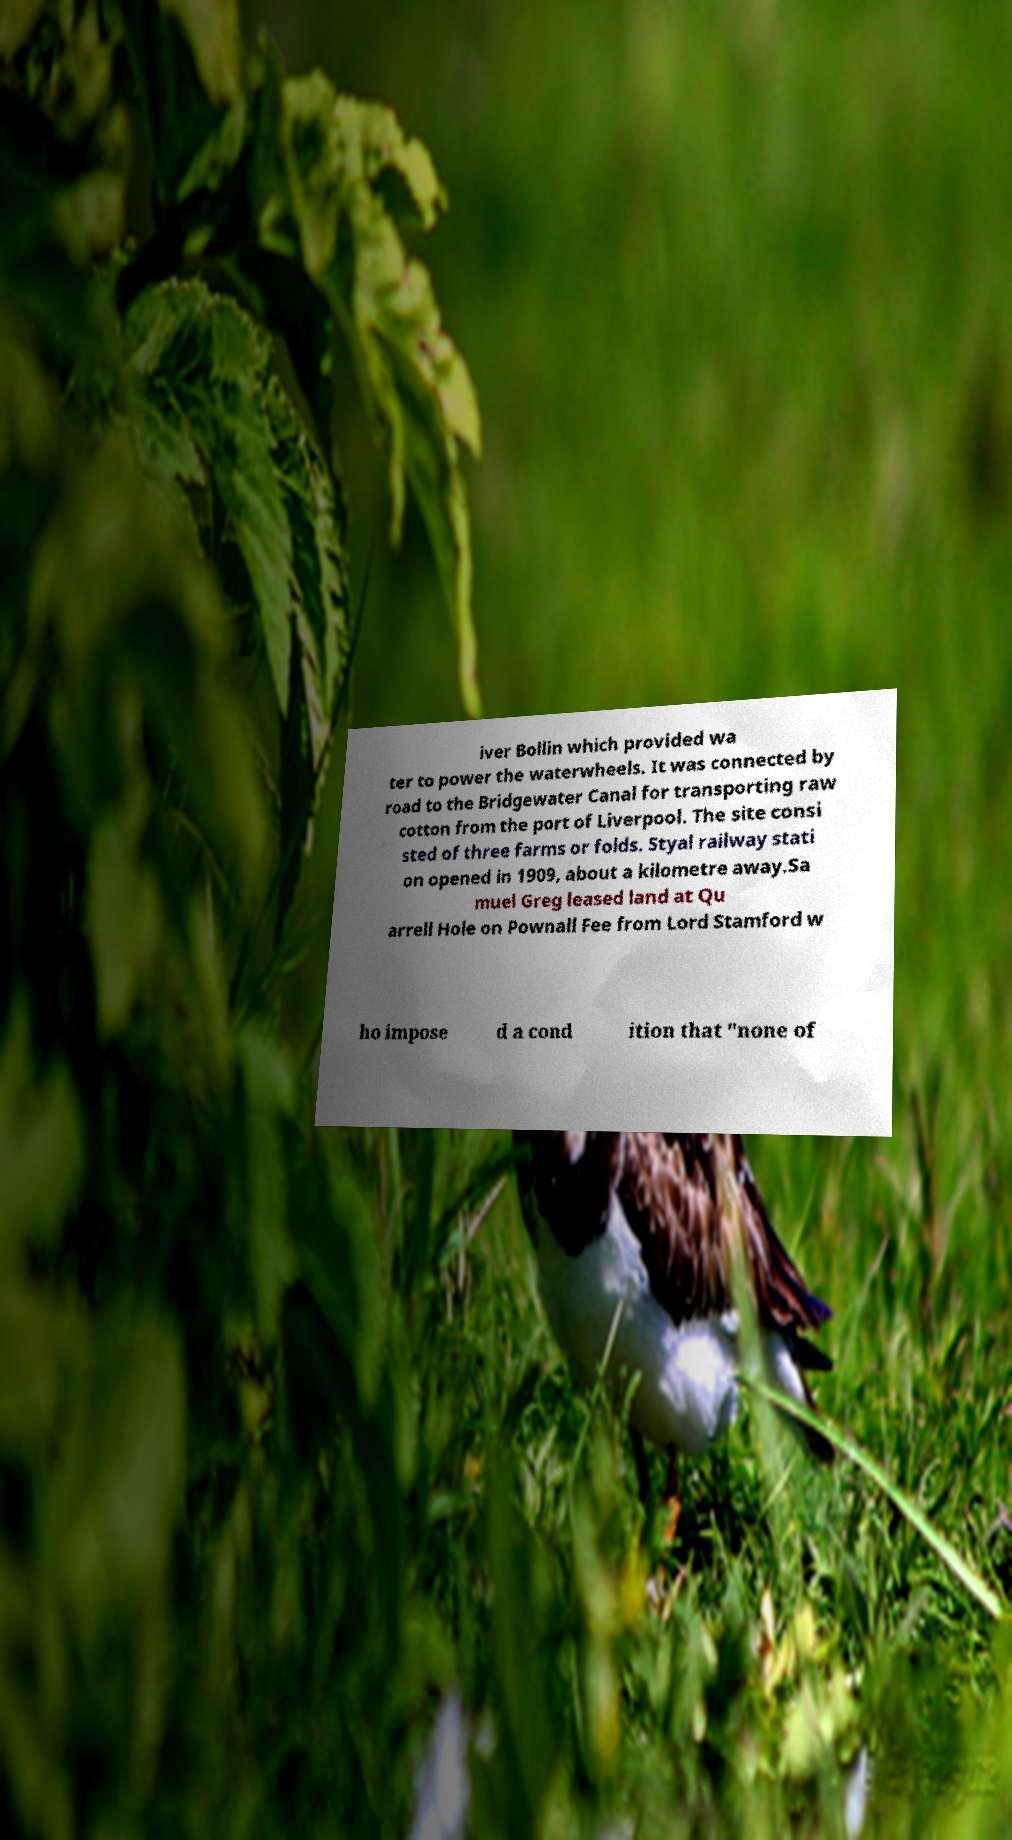For documentation purposes, I need the text within this image transcribed. Could you provide that? iver Bollin which provided wa ter to power the waterwheels. It was connected by road to the Bridgewater Canal for transporting raw cotton from the port of Liverpool. The site consi sted of three farms or folds. Styal railway stati on opened in 1909, about a kilometre away.Sa muel Greg leased land at Qu arrell Hole on Pownall Fee from Lord Stamford w ho impose d a cond ition that "none of 